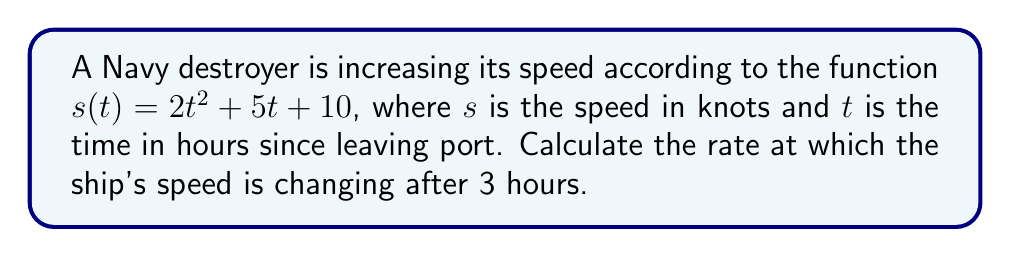Give your solution to this math problem. To solve this problem, we need to follow these steps:

1) The rate of change of speed is given by the derivative of the speed function.

2) The speed function is $s(t) = 2t^2 + 5t + 10$

3) To find the derivative, we use the power rule and constant rule:
   
   $\frac{ds}{dt} = 4t + 5$

4) This derivative function gives us the instantaneous rate of change of speed at any time $t$.

5) We want to know the rate of change after 3 hours, so we substitute $t = 3$ into our derivative function:

   $\frac{ds}{dt}|_{t=3} = 4(3) + 5 = 12 + 5 = 17$

6) Therefore, after 3 hours, the ship's speed is increasing at a rate of 17 knots per hour.
Answer: 17 knots/hour 